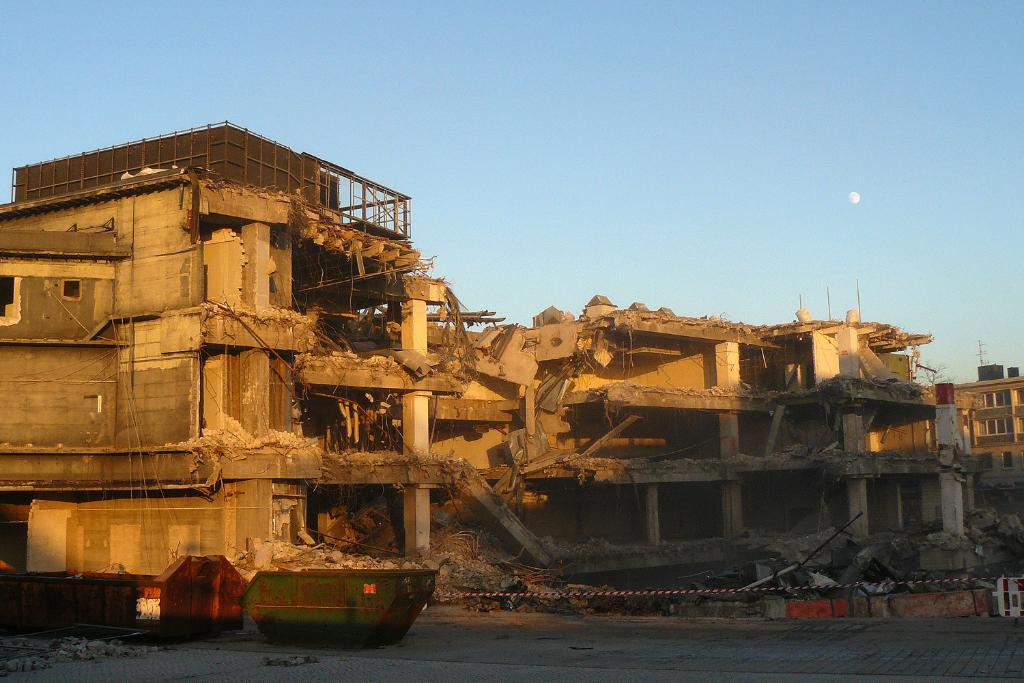What is the main subject of the image? The main subject of the image is a collapsed building. Are there any other buildings visible in the image? Yes, there is another building visible in the image. What objects can be seen in front of the building? There are two objects in front of the building. How many train tracks can be seen in the image? There are no train tracks visible in the image. What type of wheel is present on the collapsed building? There is no wheel present on the collapsed building in the image. 